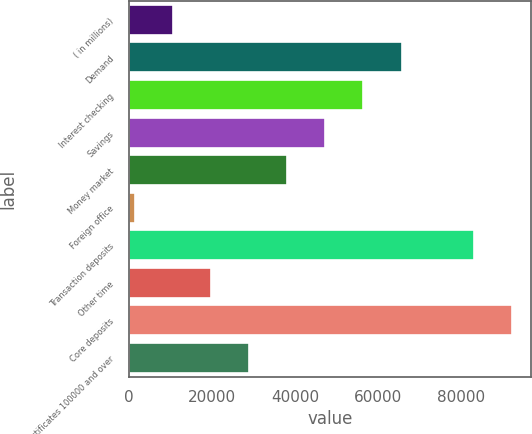<chart> <loc_0><loc_0><loc_500><loc_500><bar_chart><fcel>( in millions)<fcel>Demand<fcel>Interest checking<fcel>Savings<fcel>Money market<fcel>Foreign office<fcel>Transaction deposits<fcel>Other time<fcel>Core deposits<fcel>Certificates 100000 and over<nl><fcel>10654<fcel>65572<fcel>56419<fcel>47266<fcel>38113<fcel>1501<fcel>82915<fcel>19807<fcel>92068<fcel>28960<nl></chart> 